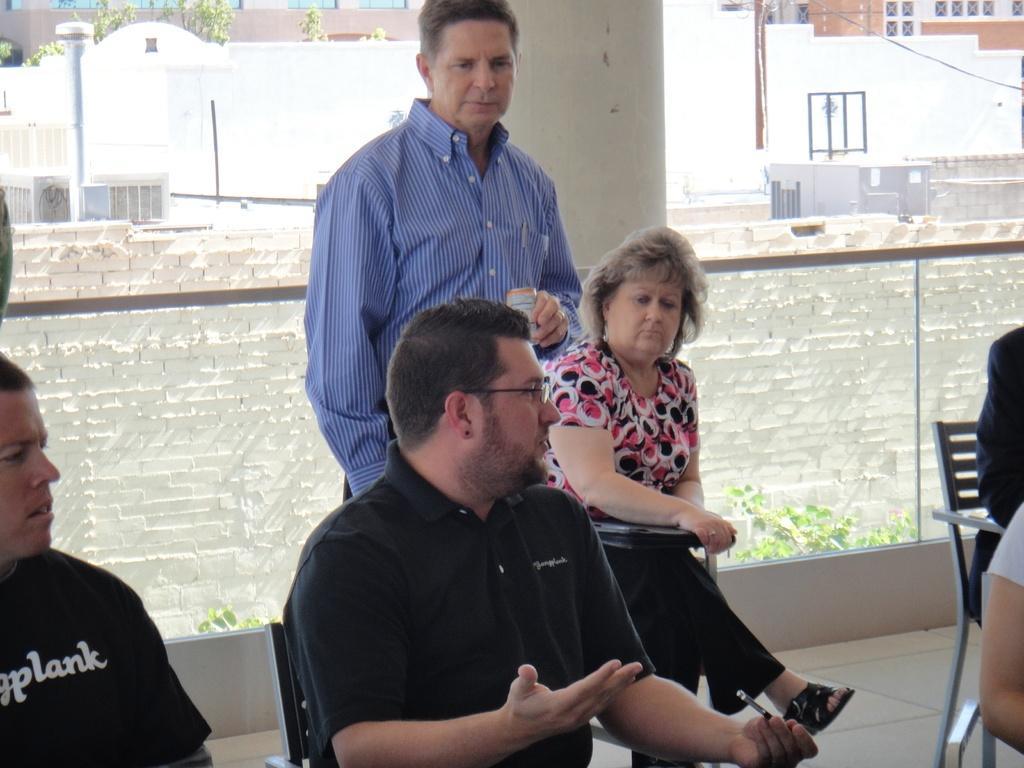Could you give a brief overview of what you see in this image? In the picture I can see people among them one man is standing and holding an object in the hand and others are sitting on chairs. In the background I can see buildings, fence, trees and some other objects. 